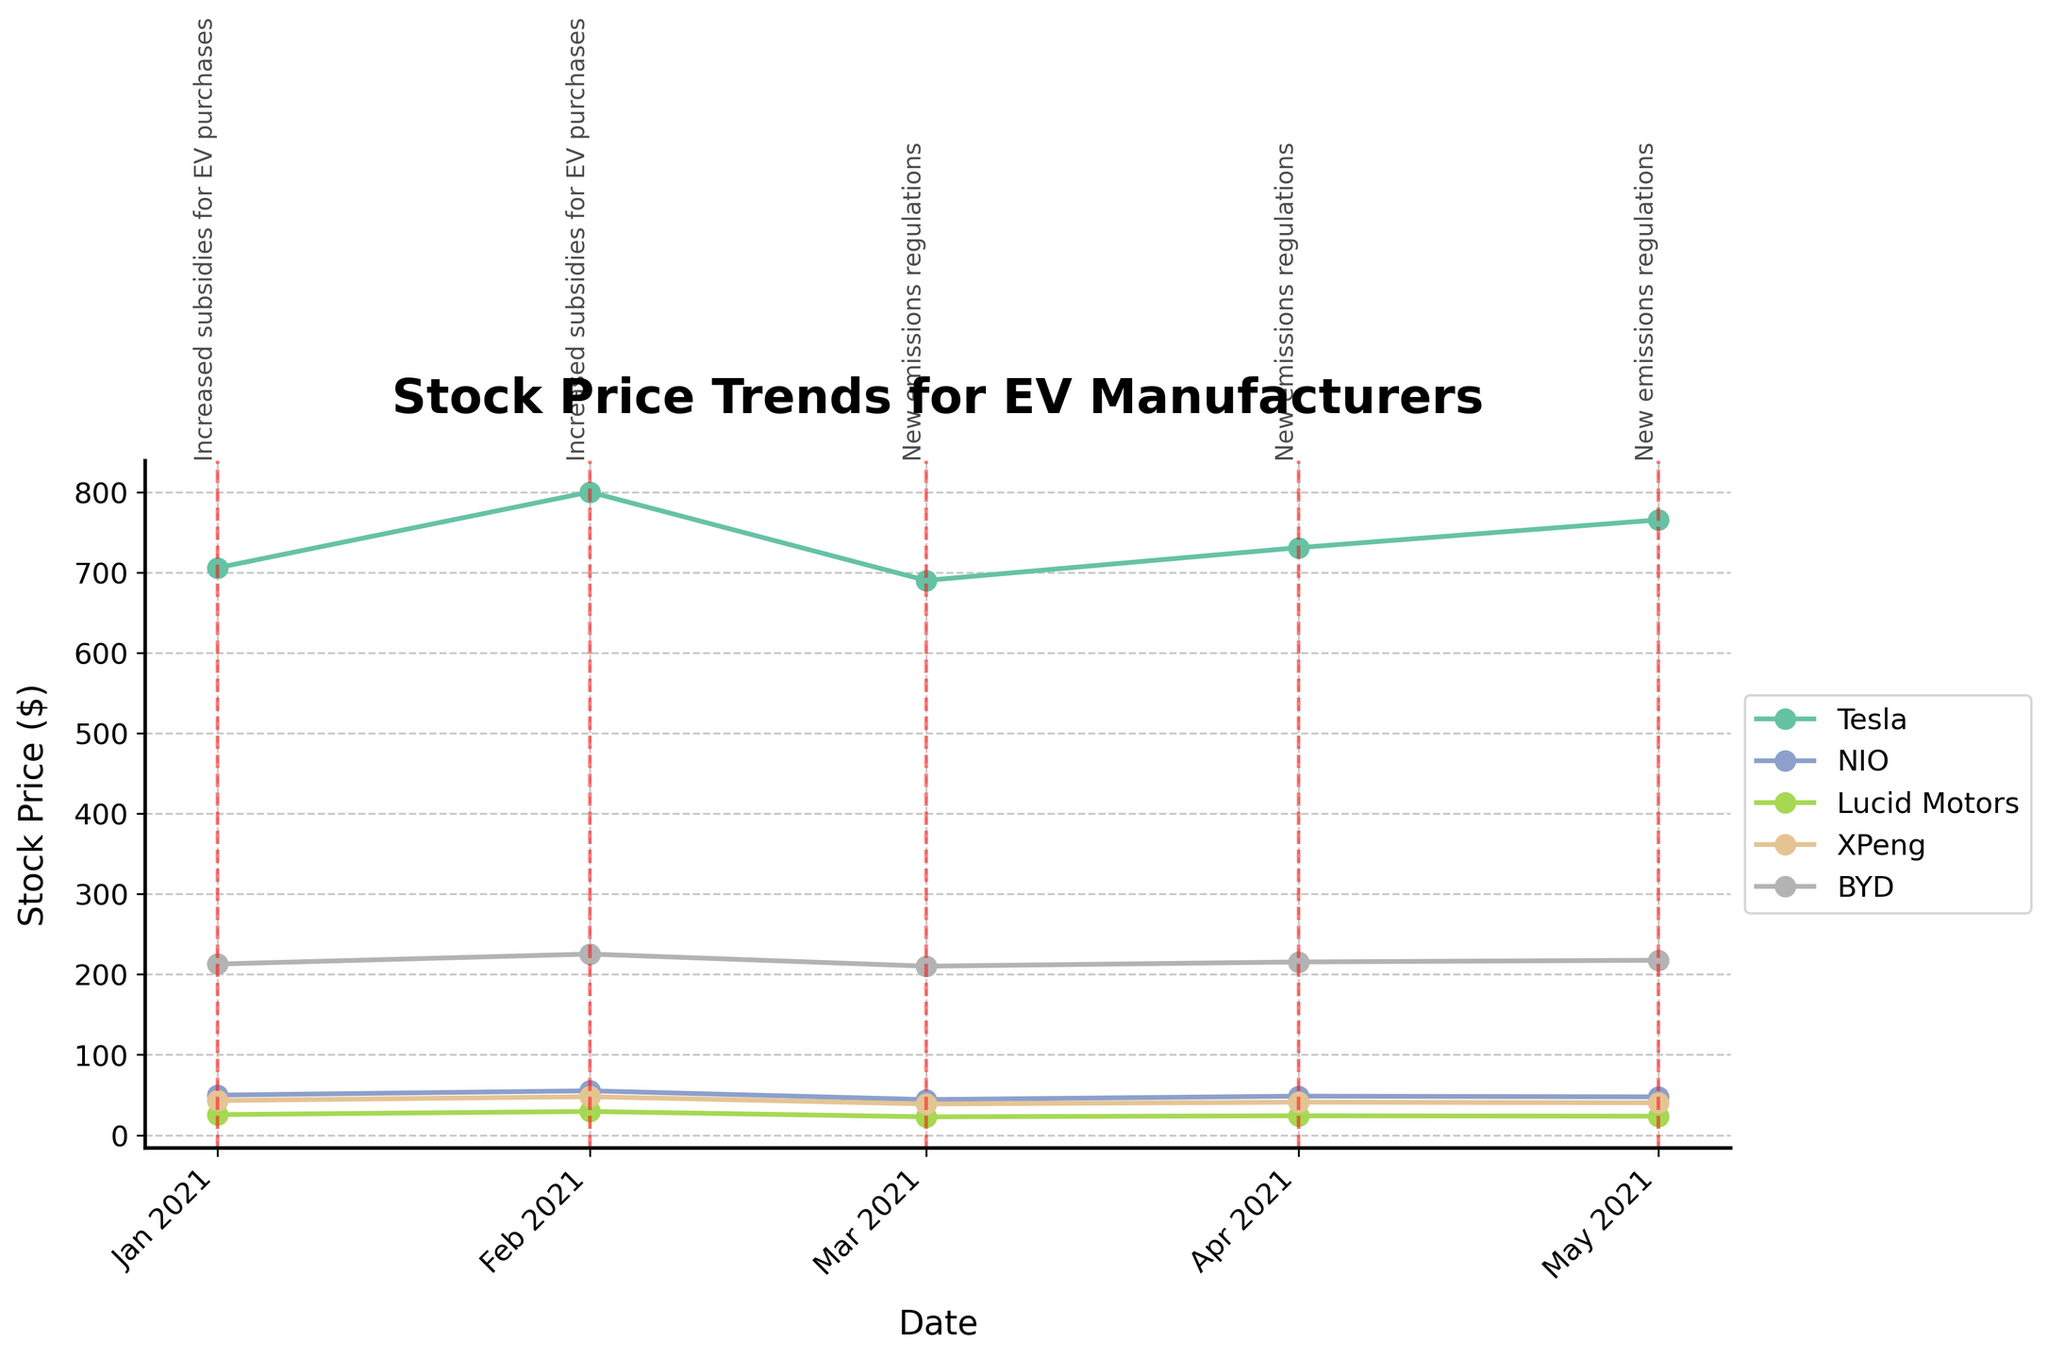What is the title of the plot? The title of the plot can be seen at the top and it reads "Stock Price Trends for EV Manufacturers."
Answer: Stock Price Trends for EV Manufacturers In which period did Tesla's stock price increase the most? Look at Tesla's stock price on the y-axis and identify the month-to-month differences. Tesla's stock price increased the most from January 2021 to February 2021, where it went from approximately $705.67 to $800.02.
Answer: January 2021 to February 2021 What was the stock price of BYD in May 2021? Look at the line plot for BYD and locate the stock price in May 2021 on the x-axis. The stock price is marked by a point on the plot.
Answer: 217.55 How did the stock price of Lucid Motors change in response to the new emissions regulations in March 2021? Examine the points and their connections in Lucid Motors' line plot between March 2021 and May 2021. The stock price decreased sharply from February 2021 ($29.45) to March 2021 ($22.75) and then slightly increased afterwards.
Answer: Decreased initially in March 2021, then slightly increased Which company showed the least volatility in stock price over the given period? Compare the stock price lines for all companies. The line for BYD shows the smallest fluctuations in stock price, indicating the least volatility.
Answer: BYD Between Tesla and NIO, whose stock price was higher in April 2021? Compare the points for Tesla and NIO on the plot in April 2021. Tesla's stock price was approximately $730.75, while NIO's was around $48.50.
Answer: Tesla What visible trend can be observed after the "Increased subsidies for EV purchases" policy change? Look at the data points marked with "Increased subsidies for EV purchases" and observe the trend lines following this policy change. Stock prices for all EV manufacturers increased immediately after the policy change.
Answer: Stock prices increased How many months show a decline in XPeng's stock price? Look at the stock price line for XPeng and count the segments where the trend is downward. XPeng's stock price declined in two periods, March 2021 and May 2021.
Answer: 2 months What is the average stock price of Tesla over the entire period? Add the stock prices of Tesla for each month and divide by the number of months (705.67 + 800.02 + 690.00 + 730.75 + 765.34) / 5.
Answer: 738.36 Which company experienced the steepest decline in stock price in March 2021? Evaluate the decrease in stock price for each company in March 2021. Lucid Motors dipped from $29.45 in February to $22.75 in March, a $6.70 drop, larger than any other company.
Answer: Lucid Motors 